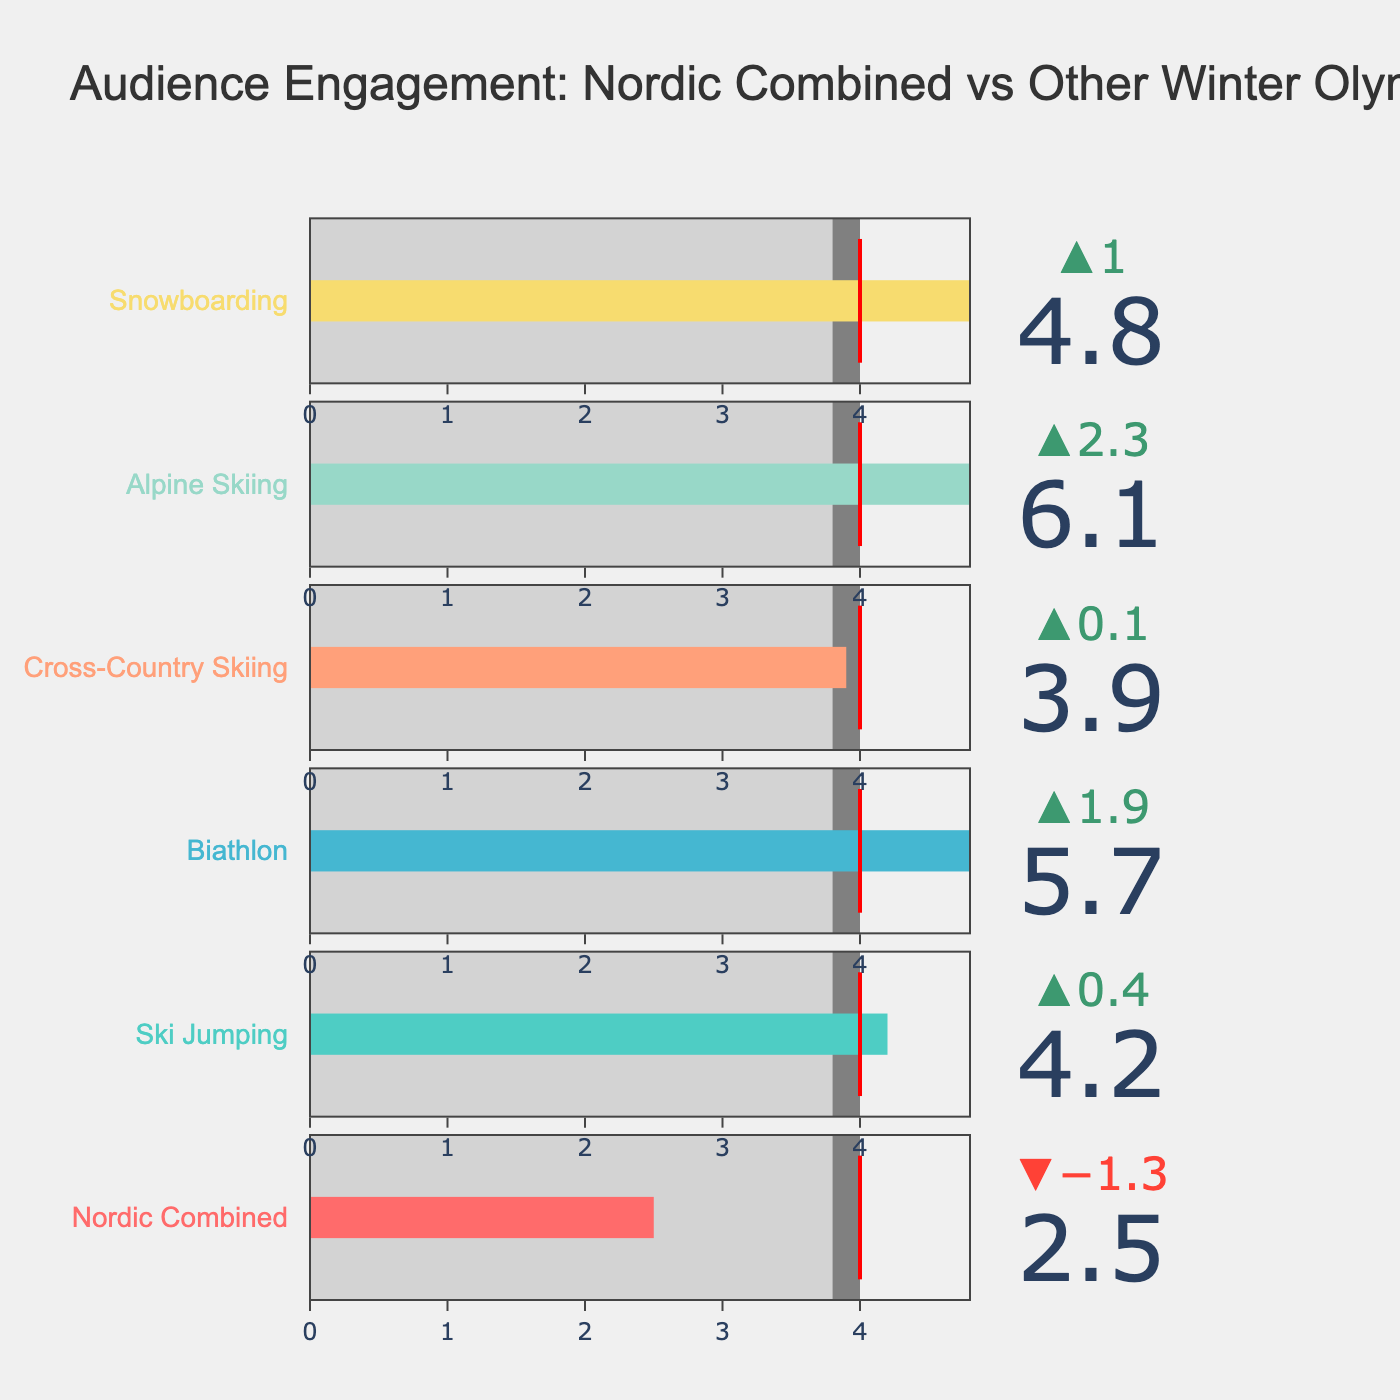What's the title of the figure? The title of the figure is located at the top and provides the main topic of the visualization. By observing, we see it reads: 'Audience Engagement: Nordic Combined vs Other Winter Olympic Sports'
Answer: Audience Engagement: Nordic Combined vs Other Winter Olympic Sports Which sport has the highest average viewership? To determine the sport with the highest average viewership, we compare the values of the 'Average Viewership (millions)' for each sport. Alpine Skiing has the highest value, as seen on the bar reaching the furthest right.
Answer: Alpine Skiing How does Nordic Combined's average viewership compare to its target? To compare the average viewership for Nordic Combined with its target, we look at the bar representing Nordic Combined and note its length relative to the target mark (red line). The average viewership of 2.5 million is below the target of 4.0 million.
Answer: Below target What is the difference between the average viewership of Snowboarding and Cross-Country Skiing? To find this difference, we subtract the average viewership of Cross-Country Skiing (3.9 million) from Snowboarding (4.8 million). \(4.8 - 3.9 = 0.9\).
Answer: 0.9 million Which sport’s delta value is the highest, and what is its significance? To find the sport with the highest delta value, observe the delta labels at the top of each bar. Biathlon has the highest delta of 1.9, indicating its average viewership is the highest above the comparative measure.
Answer: Biathlon, 1.9 million more than the comparative measure What color represents Alpine Skiing in the bullet chart? By examining the color associated with the Alpine Skiing bar, we see it is represented by a yellowish color.
Answer: Yellowish What is the average viewership of Ski Jumping, and how does it compare to the comparative measure? The average viewership of Ski Jumping, observed from the bar, is 4.2 million. Compared to the comparative measure of 3.8 million, it is 0.4 million higher.
Answer: 4.2 million, 0.4 million higher Is there any sport that exactly hits the target viewership? To find if any sport reaches the target viewership, we compare each average viewership to the target of 4.0 million. None of the bars exactly hit the target.
Answer: No Which sport has its average viewership closest to the target and by how much? To determine this, we calculate the absolute difference between each sport's average viewership and the target of 4.0 million. Cross-Country Skiing is the closest with an average viewership of 3.9 million, which is 0.1 million below the target.
Answer: Cross-Country Skiing, 0.1 million below 